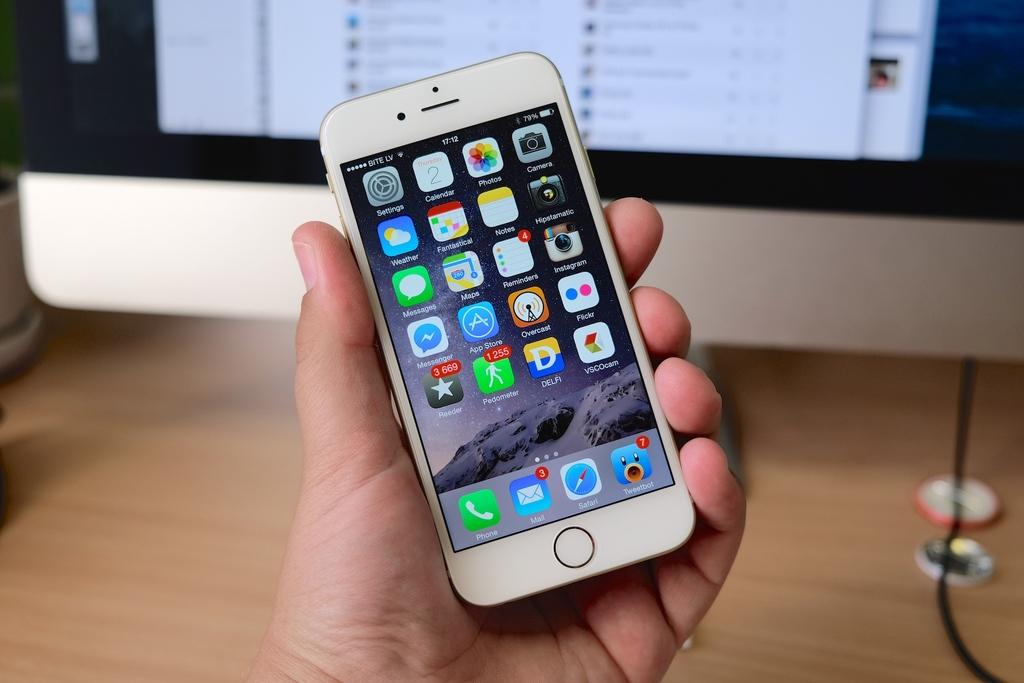What object is being held by the person in the image? There is a mobile phone in the person's hand. Where is the mobile phone located in the image? The mobile phone is in the center of the image. What can be seen in the background of the image? There is a monitor and a table in the background of the image. What type of toys can be seen on the table in the image? There are no toys present in the image; the table in the background contains a monitor. 